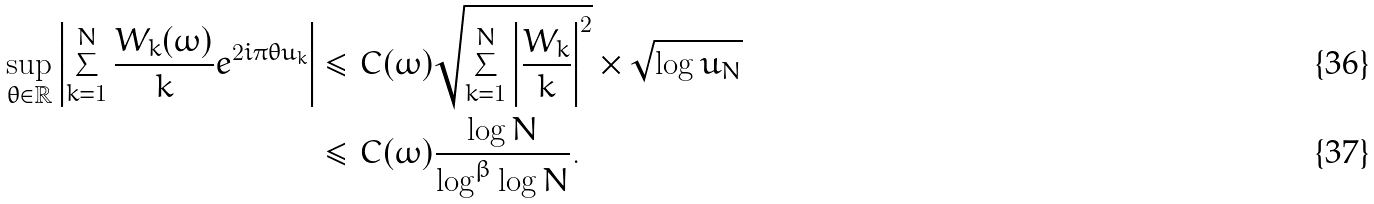Convert formula to latex. <formula><loc_0><loc_0><loc_500><loc_500>\sup _ { \theta \in \mathbb { R } } \left | \sum _ { k = 1 } ^ { N } \frac { W _ { k } ( \omega ) } { k } e ^ { 2 i \pi \theta u _ { k } } \right | & \leq C ( \omega ) \sqrt { \sum _ { k = 1 } ^ { N } \left | \frac { W _ { k } } { k } \right | ^ { 2 } } \times \sqrt { \log u _ { N } } \\ & \leq C ( \omega ) \frac { \log N } { \log ^ { \beta } \log N } .</formula> 